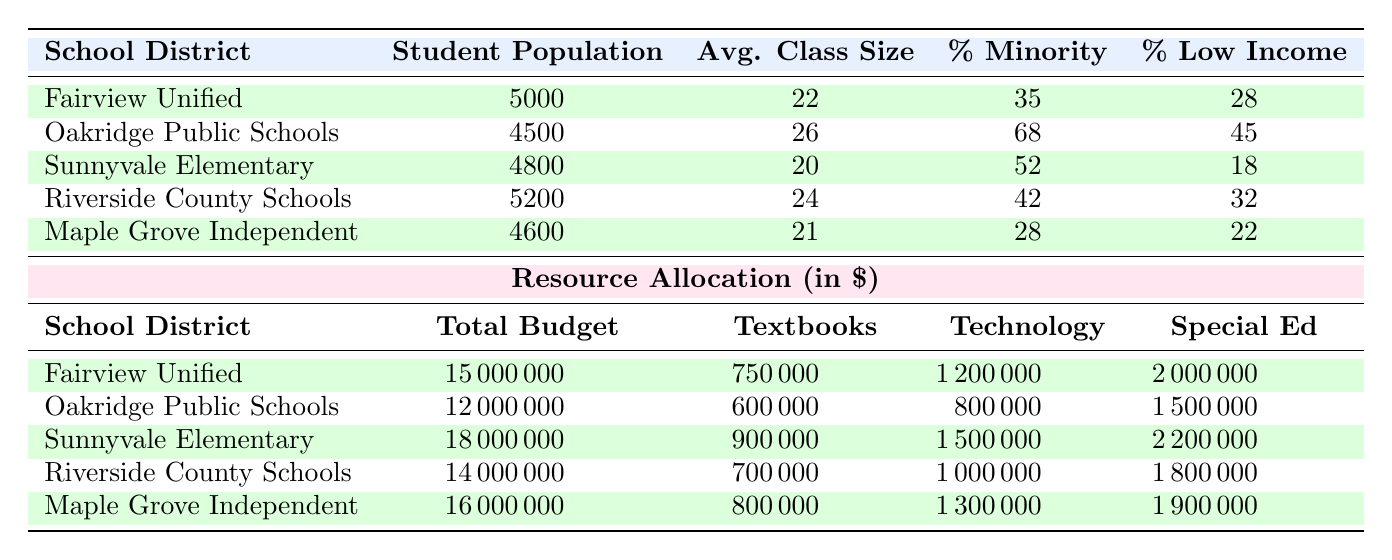What is the total budget of Sunnyvale Elementary? The total budget for Sunnyvale Elementary is listed directly in the table under the "Total Budget" column, which shows a value of 18000000.
Answer: 18000000 Which school district has the highest percentage of minority students? By examining the "Percentage Minority" column, Oakridge Public Schools has the highest value at 68, which is greater than all the other districts.
Answer: Oakridge Public Schools What is the average class size across all districts? To find the average class size, sum the values of the "Avg. Class Size" column (22 + 26 + 20 + 24 + 21 = 113) and then divide by the number of districts (113 / 5 = 22.6).
Answer: 22.6 True or False: Riverside County Schools has a lower total budget than Fairview Unified. Comparing the "Total Budget" values, Riverside County Schools has 14000000 while Fairview Unified has 15000000. Since 14000000 is less than 15000000, the statement is true.
Answer: True What is the total allocation for technology across all school districts? Adding the "Technology" allocation for each district gives (1200000 + 800000 + 1500000 + 1000000 + 1300000 = 6800000). This is the total allocation for technology across all districts.
Answer: 6800000 Which district allocated the most funds for special education? Looking directly at the "Special Ed" column, Sunnyvale Elementary allocated the most at 2200000, more than the other districts.
Answer: Sunnyvale Elementary Calculate the difference in average class size between the district with the highest and the lowest average class size. The highest average class size is 26 (Oakridge Public Schools) and the lowest is 20 (Sunnyvale Elementary). Thus, the difference is 26 - 20 = 6.
Answer: 6 Is the percentage of low-income students in Maple Grove Independent greater than the percentage in Fairview Unified? The percentage of low-income students for Maple Grove Independent is 22, while for Fairview Unified it is 28. Since 22 is less than 28, the statement is false.
Answer: False Which district has the lowest free lunch program allocation? By looking in the "Free Lunch Program" column, Oakridge Public Schools shows the allocation of 1000000, which is the lowest among the other districts.
Answer: Oakridge Public Schools 